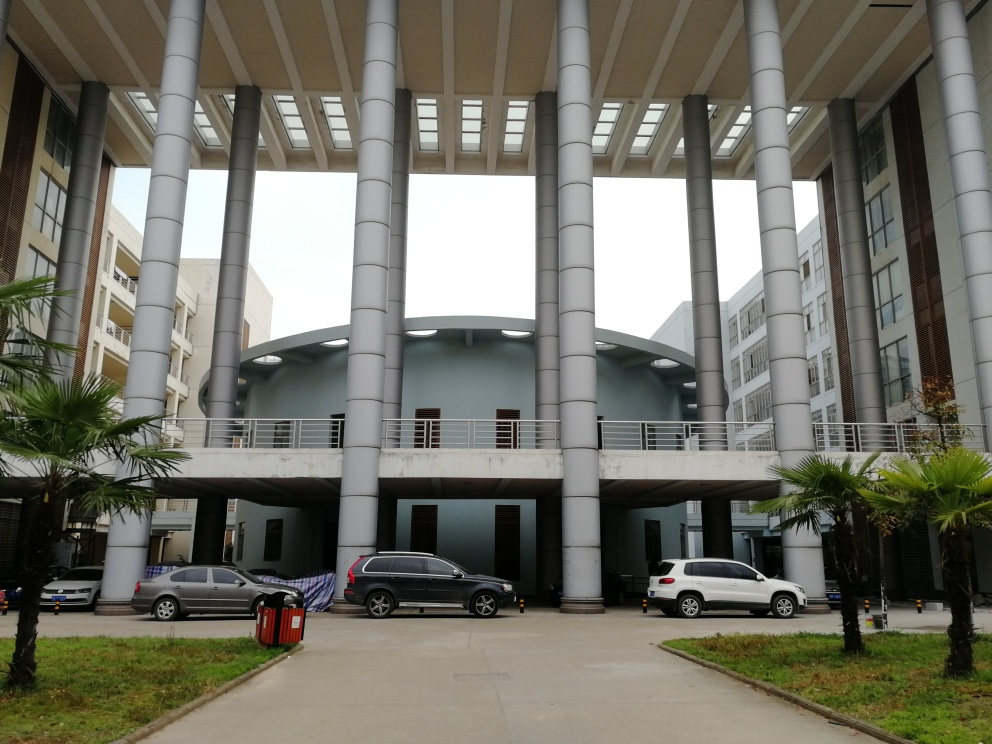What might be the purpose of this building complex? Judging by the image, this building complex appears to be a commercial or institutional space, such as a university or a corporate campus. The presence of walkways and the architectural design suggests it is a space designed for significant pedestrian traffic and possibly multiple uses, including offices, educational facilities, or public services. 